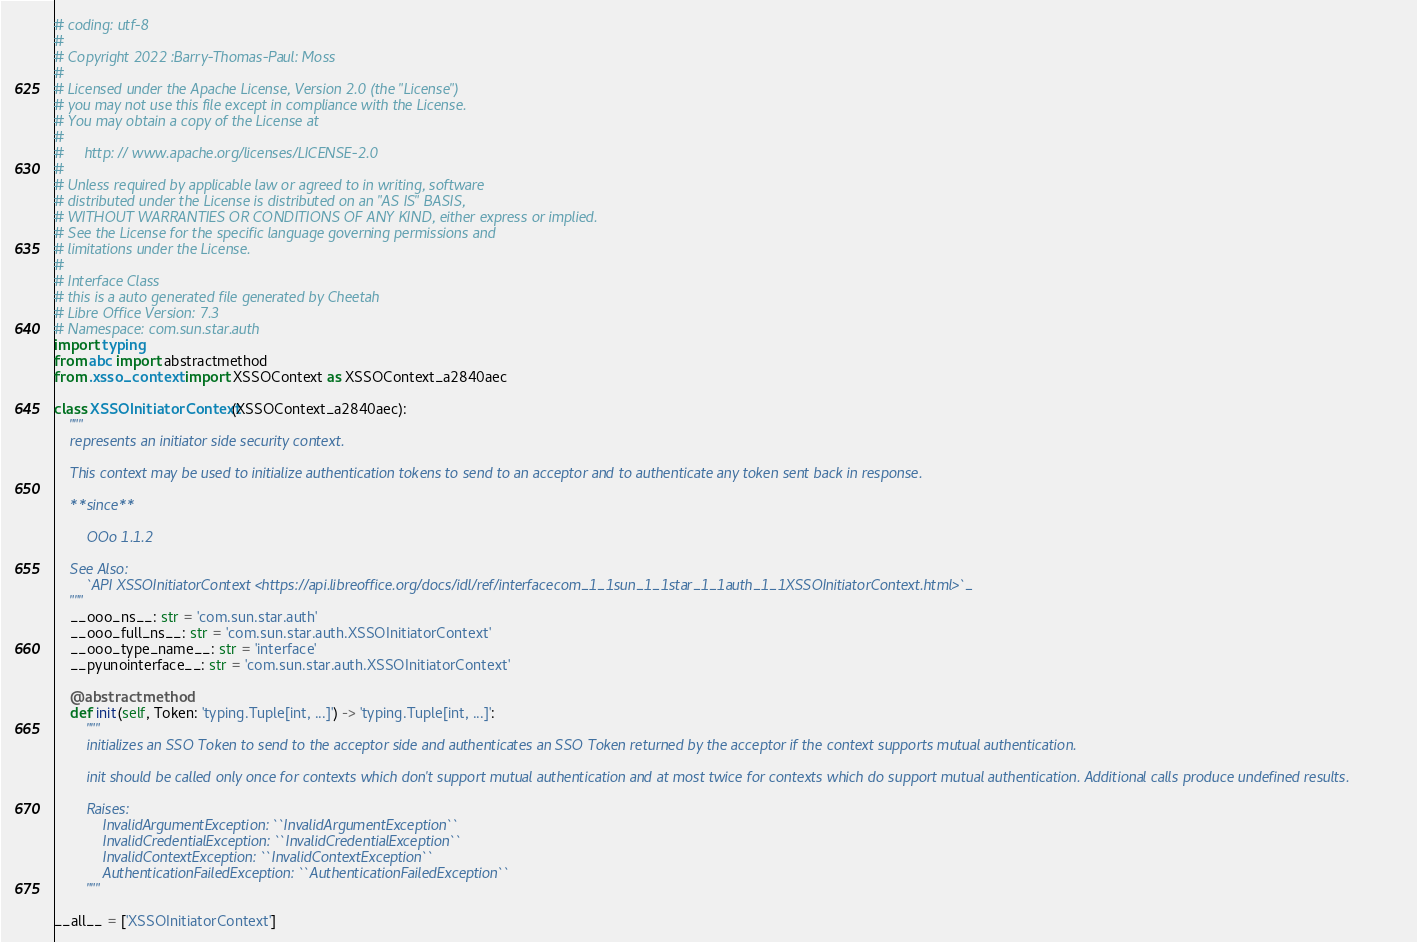Convert code to text. <code><loc_0><loc_0><loc_500><loc_500><_Python_># coding: utf-8
#
# Copyright 2022 :Barry-Thomas-Paul: Moss
#
# Licensed under the Apache License, Version 2.0 (the "License")
# you may not use this file except in compliance with the License.
# You may obtain a copy of the License at
#
#     http: // www.apache.org/licenses/LICENSE-2.0
#
# Unless required by applicable law or agreed to in writing, software
# distributed under the License is distributed on an "AS IS" BASIS,
# WITHOUT WARRANTIES OR CONDITIONS OF ANY KIND, either express or implied.
# See the License for the specific language governing permissions and
# limitations under the License.
#
# Interface Class
# this is a auto generated file generated by Cheetah
# Libre Office Version: 7.3
# Namespace: com.sun.star.auth
import typing
from abc import abstractmethod
from .xsso_context import XSSOContext as XSSOContext_a2840aec

class XSSOInitiatorContext(XSSOContext_a2840aec):
    """
    represents an initiator side security context.
    
    This context may be used to initialize authentication tokens to send to an acceptor and to authenticate any token sent back in response.
    
    **since**
    
        OOo 1.1.2

    See Also:
        `API XSSOInitiatorContext <https://api.libreoffice.org/docs/idl/ref/interfacecom_1_1sun_1_1star_1_1auth_1_1XSSOInitiatorContext.html>`_
    """
    __ooo_ns__: str = 'com.sun.star.auth'
    __ooo_full_ns__: str = 'com.sun.star.auth.XSSOInitiatorContext'
    __ooo_type_name__: str = 'interface'
    __pyunointerface__: str = 'com.sun.star.auth.XSSOInitiatorContext'

    @abstractmethod
    def init(self, Token: 'typing.Tuple[int, ...]') -> 'typing.Tuple[int, ...]':
        """
        initializes an SSO Token to send to the acceptor side and authenticates an SSO Token returned by the acceptor if the context supports mutual authentication.
        
        init should be called only once for contexts which don't support mutual authentication and at most twice for contexts which do support mutual authentication. Additional calls produce undefined results.

        Raises:
            InvalidArgumentException: ``InvalidArgumentException``
            InvalidCredentialException: ``InvalidCredentialException``
            InvalidContextException: ``InvalidContextException``
            AuthenticationFailedException: ``AuthenticationFailedException``
        """

__all__ = ['XSSOInitiatorContext']

</code> 